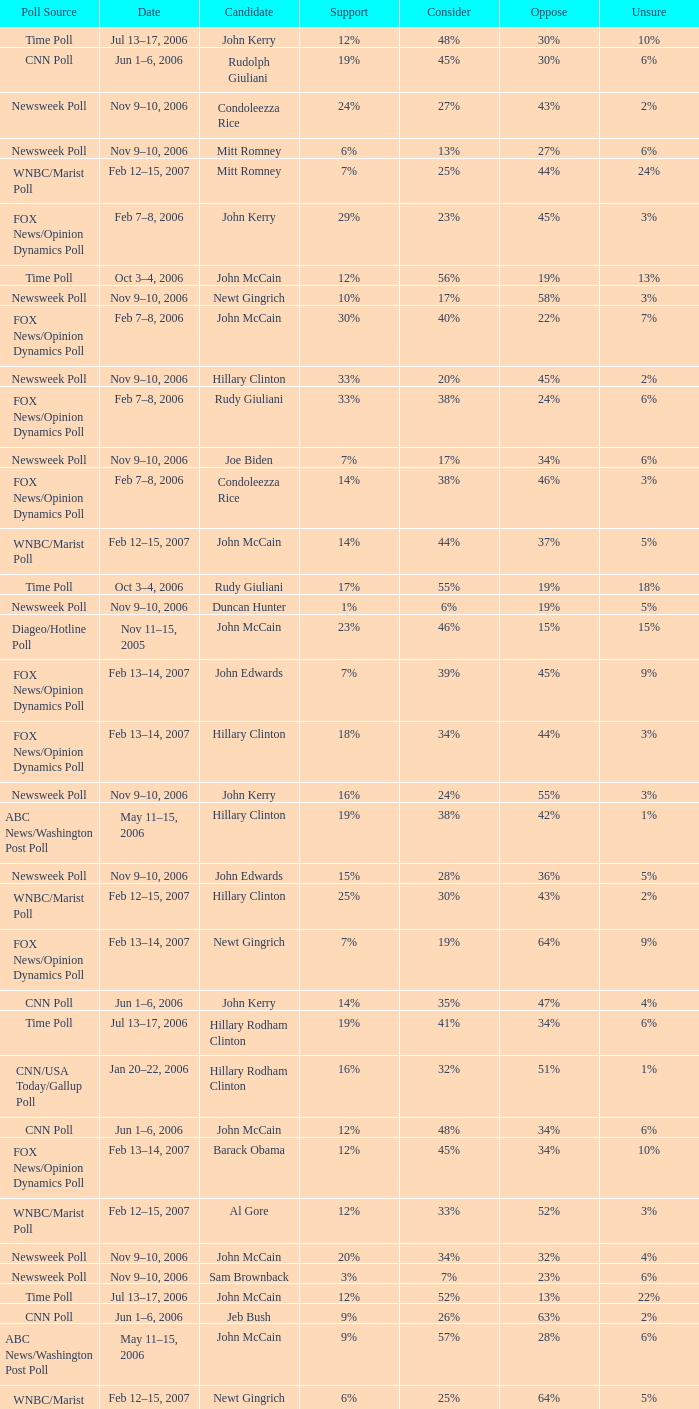What percentage of people were opposed to the candidate based on the WNBC/Marist poll that showed 8% of people were unsure? 35%. 